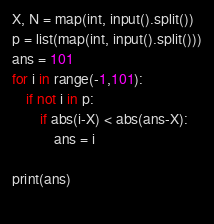Convert code to text. <code><loc_0><loc_0><loc_500><loc_500><_Python_>X, N = map(int, input().split())
p = list(map(int, input().split()))
ans = 101
for i in range(-1,101):
    if not i in p:
        if abs(i-X) < abs(ans-X):
            ans = i

print(ans)
    </code> 